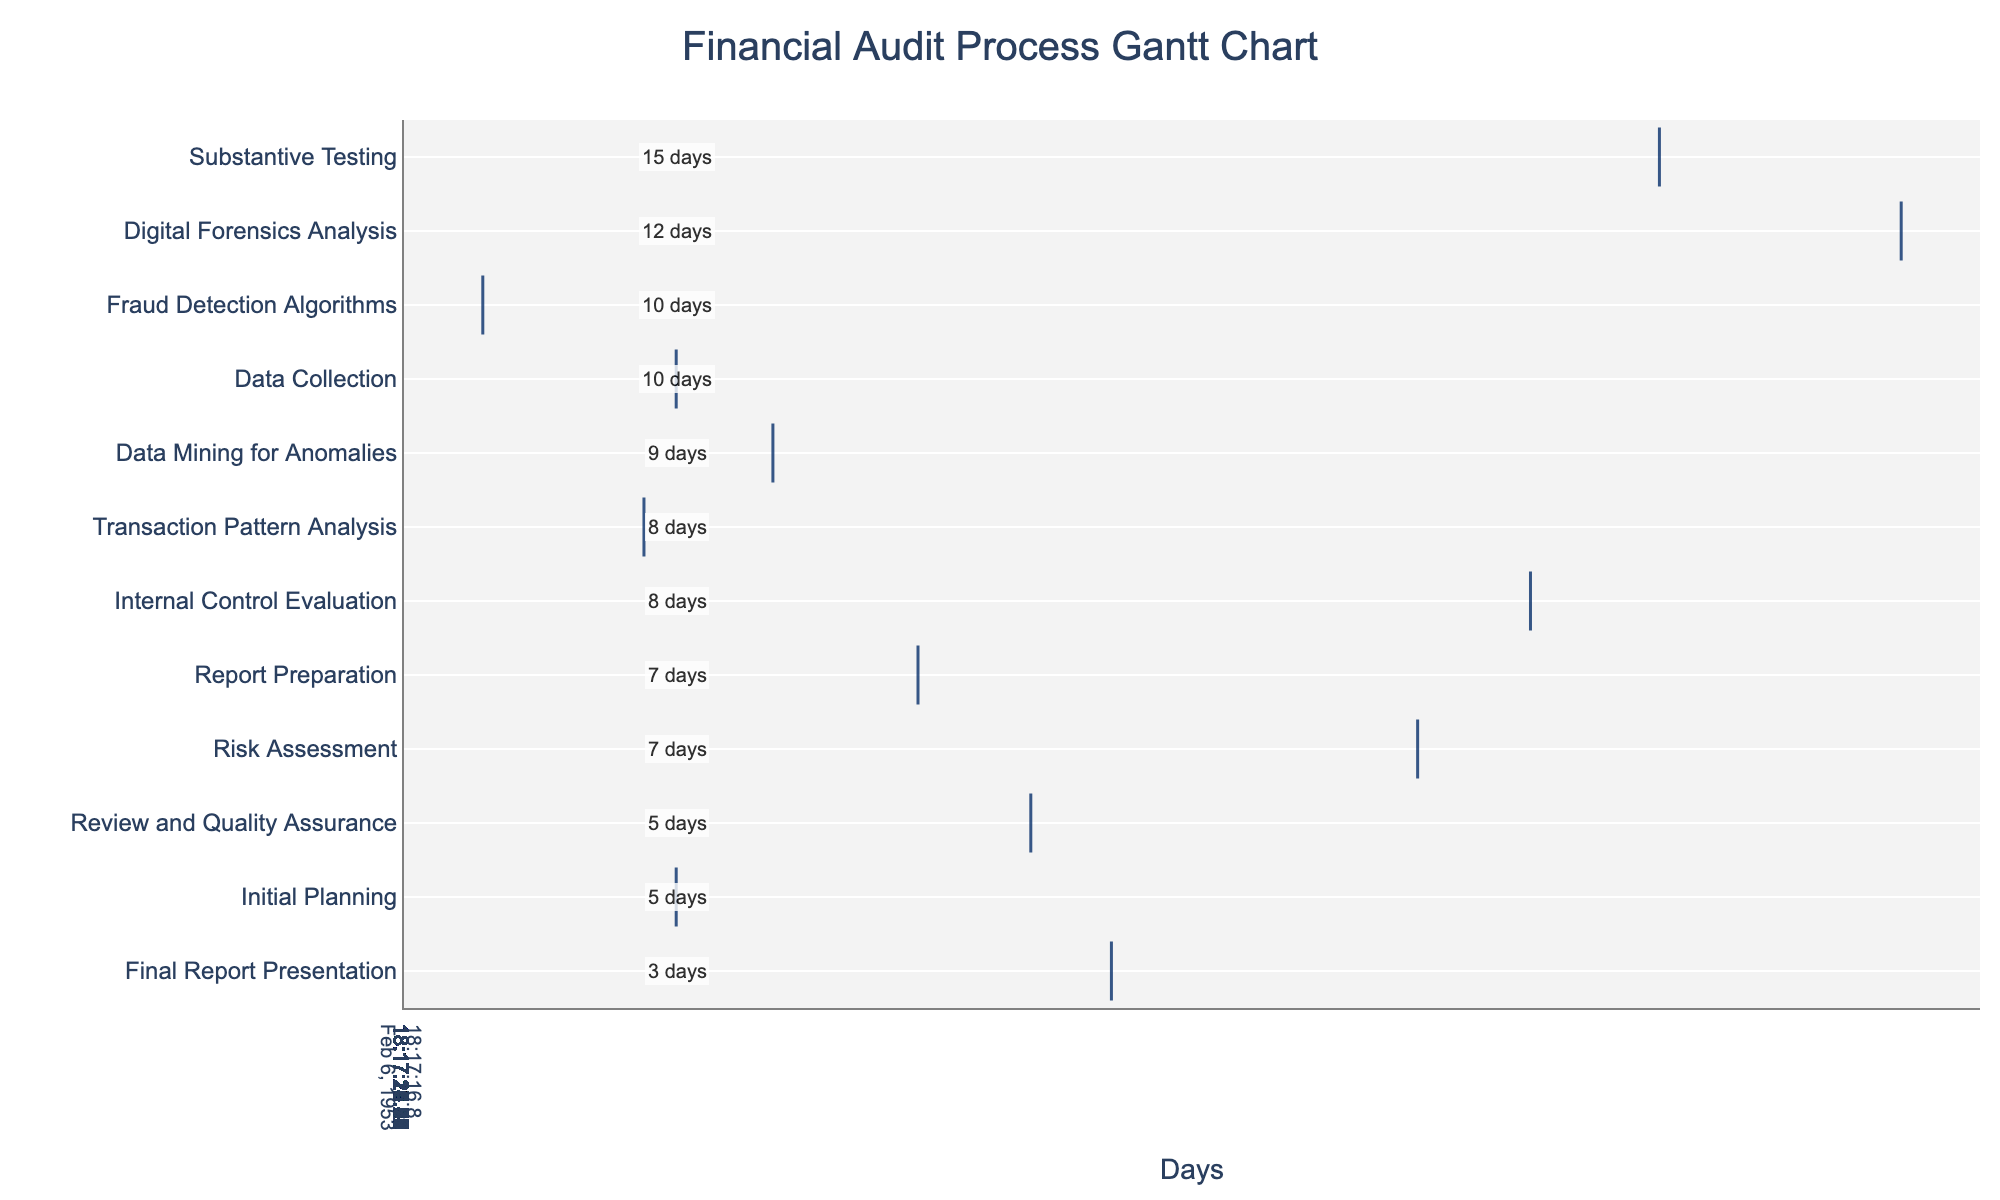What is the title of the Gantt chart? The title of the Gantt chart is prominently displayed at the top of the figure, making it easily identifiable.
Answer: Financial Audit Process Gantt Chart How many days does the Data Collection phase last? Under the "Task" column, find the row labeled "Data Collection." The "Duration" column in the same row indicates the number of days this task lasts.
Answer: 10 days Which audit phase starts on day 46? Locate the "Start" column and look for the value 46. The corresponding audit phase in the "Task" column is what we need to identify.
Answer: Digital Forensics Analysis How long does the entire financial audit process take? The start of the process is at day 1 (Initial Planning), and the end of the process is at day 100 (Final Report Presentation). The total duration is the difference between these two days.
Answer: 100 days Which task has the shortest duration, and how many days does it last? By reviewing the "Duration" column, identify the smallest value and the corresponding task in the "Task" column.
Answer: Final Report Presentation, 3 days What is the combined duration of Risk Assessment and Internal Control Evaluation? Find the durations of "Risk Assessment" and "Internal Control Evaluation" in the "Duration" column and add them together: 7 days + 8 days = 15 days.
Answer: 15 days Which tasks follow immediately after Substantive Testing? Identify the "End" time for "Substantive Testing" by adding its duration to its start time. Then look for tasks that start immediately after this end time. The end time for Substantive Testing is day 46, so identify tasks starting after day 46.
Answer: Digital Forensics Analysis Which task is represented with the color green in the Gantt chart? To determine the specific task represented by the color green, look for the subtasks in the chart that have green bars. Color codes in Gantt charts typically represent the sequence of tasks, so one can cross-reference this with the audit phases. Due to lack of specific color information here, the answer should be derived by visual inspection of the chart provided.
Answer: (Assumed based on sequence but typically needs visual validation) What is the average duration of all tasks in this Gantt chart? Sum the durations of all tasks and divide by the total number of tasks. Sum = 5+10+7+8+15+12+10+8+9+7+5+3 = 99 days. There are 12 tasks. The average duration is 99/12.
Answer: 8.25 days 